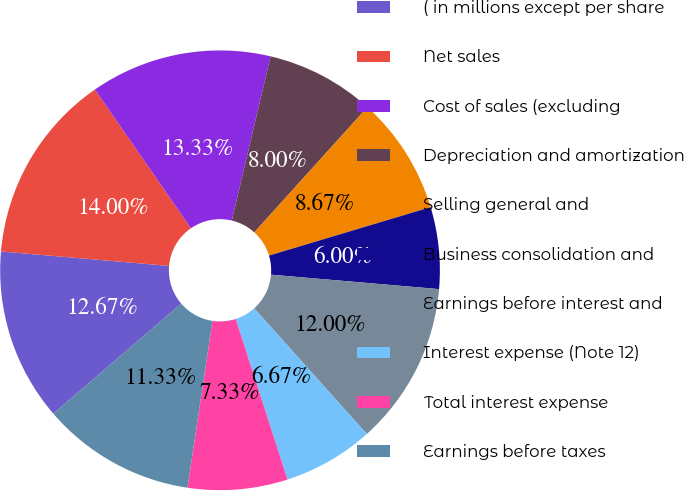Convert chart. <chart><loc_0><loc_0><loc_500><loc_500><pie_chart><fcel>( in millions except per share<fcel>Net sales<fcel>Cost of sales (excluding<fcel>Depreciation and amortization<fcel>Selling general and<fcel>Business consolidation and<fcel>Earnings before interest and<fcel>Interest expense (Note 12)<fcel>Total interest expense<fcel>Earnings before taxes<nl><fcel>12.67%<fcel>14.0%<fcel>13.33%<fcel>8.0%<fcel>8.67%<fcel>6.0%<fcel>12.0%<fcel>6.67%<fcel>7.33%<fcel>11.33%<nl></chart> 